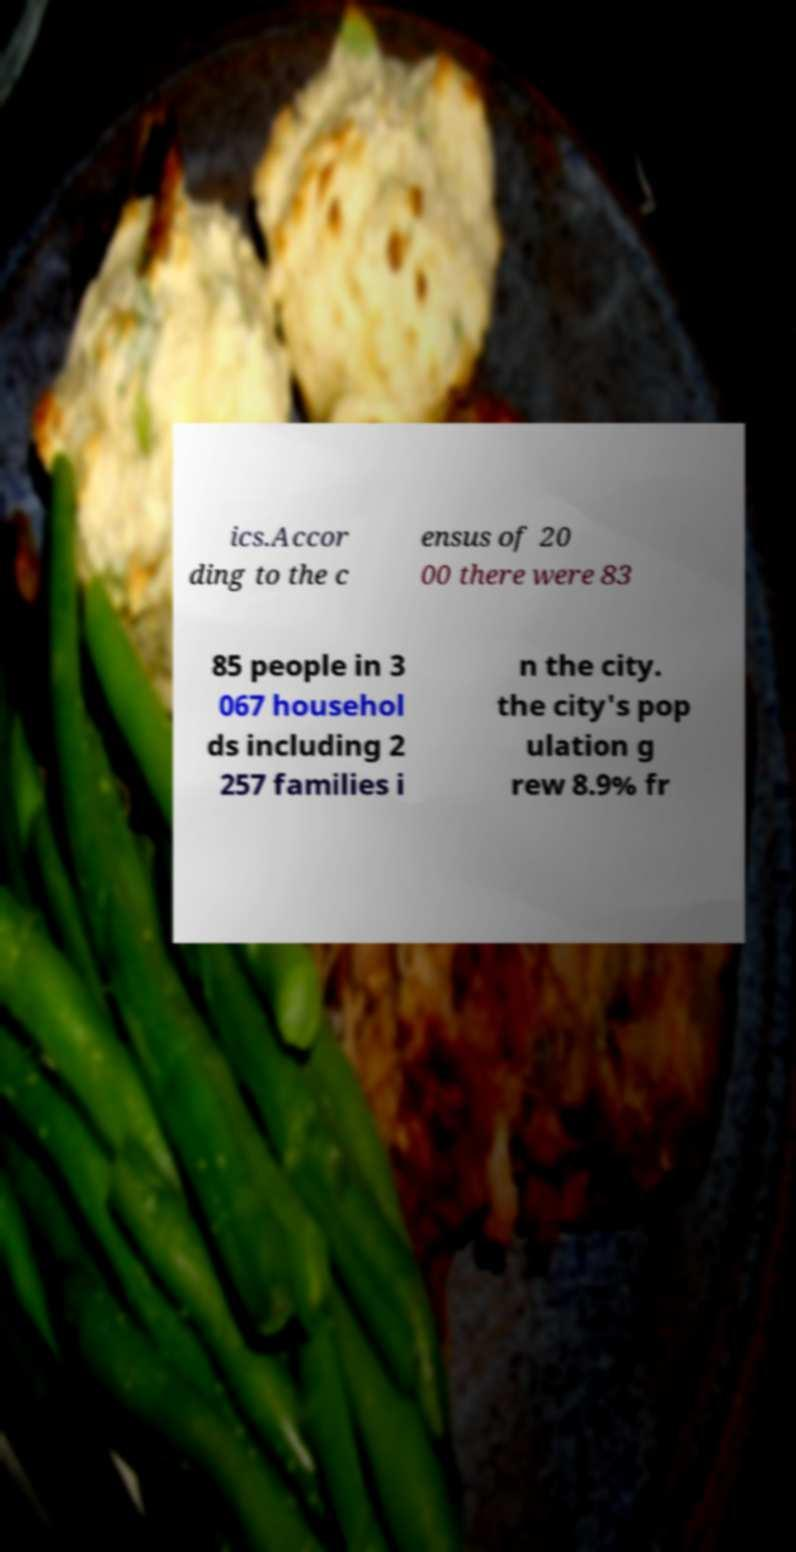Can you read and provide the text displayed in the image?This photo seems to have some interesting text. Can you extract and type it out for me? ics.Accor ding to the c ensus of 20 00 there were 83 85 people in 3 067 househol ds including 2 257 families i n the city. the city's pop ulation g rew 8.9% fr 